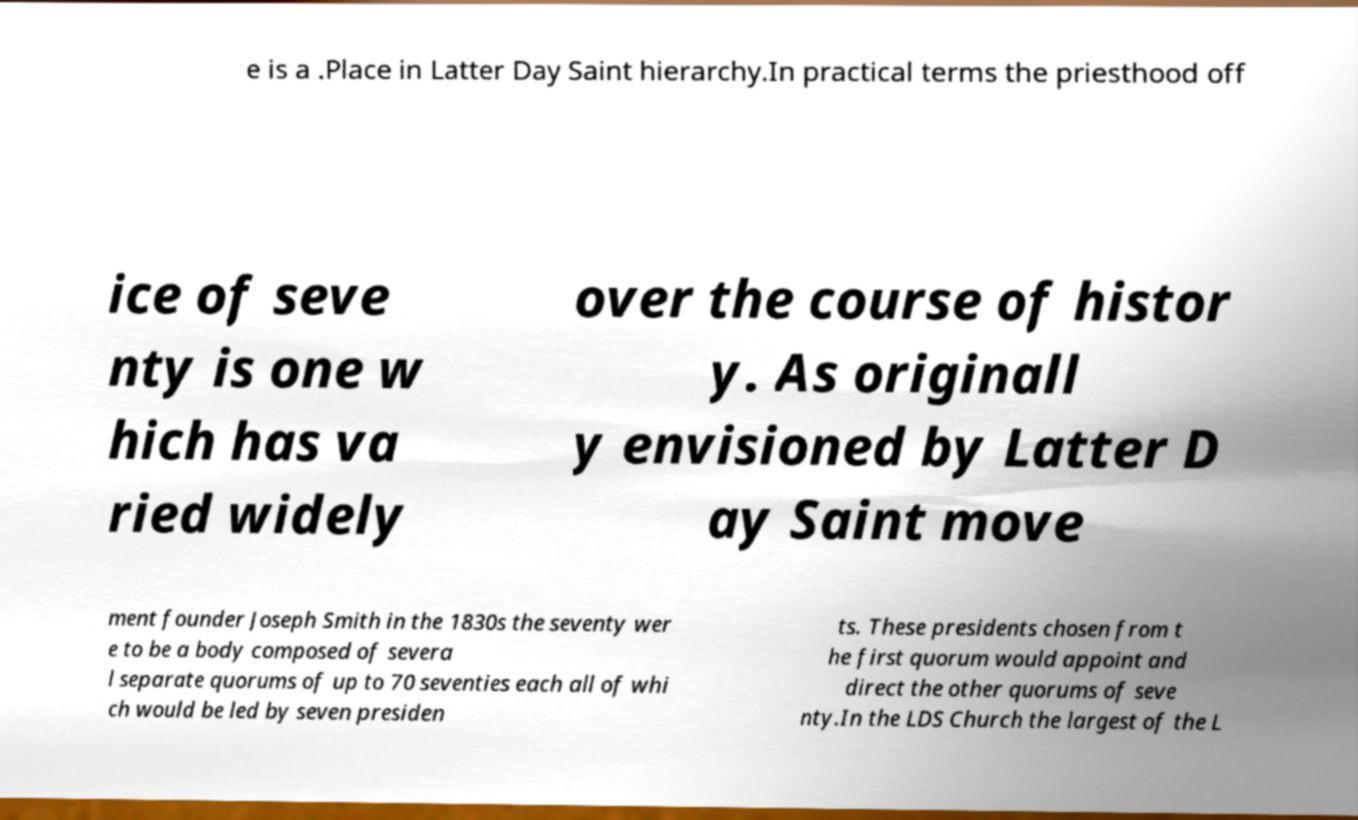Please read and relay the text visible in this image. What does it say? e is a .Place in Latter Day Saint hierarchy.In practical terms the priesthood off ice of seve nty is one w hich has va ried widely over the course of histor y. As originall y envisioned by Latter D ay Saint move ment founder Joseph Smith in the 1830s the seventy wer e to be a body composed of severa l separate quorums of up to 70 seventies each all of whi ch would be led by seven presiden ts. These presidents chosen from t he first quorum would appoint and direct the other quorums of seve nty.In the LDS Church the largest of the L 